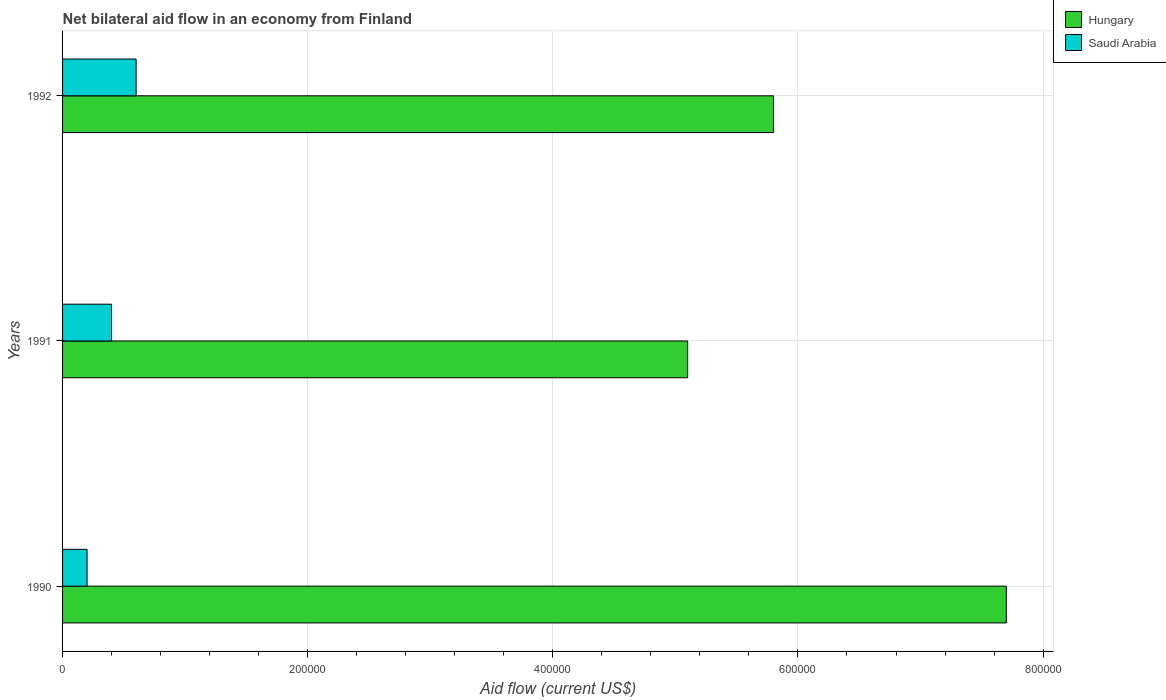How many bars are there on the 2nd tick from the top?
Keep it short and to the point. 2. In how many cases, is the number of bars for a given year not equal to the number of legend labels?
Provide a short and direct response. 0. What is the net bilateral aid flow in Hungary in 1992?
Your answer should be compact. 5.80e+05. Across all years, what is the maximum net bilateral aid flow in Hungary?
Your answer should be compact. 7.70e+05. Across all years, what is the minimum net bilateral aid flow in Hungary?
Give a very brief answer. 5.10e+05. In which year was the net bilateral aid flow in Saudi Arabia minimum?
Your answer should be compact. 1990. What is the total net bilateral aid flow in Hungary in the graph?
Keep it short and to the point. 1.86e+06. What is the difference between the net bilateral aid flow in Hungary in 1990 and that in 1991?
Ensure brevity in your answer.  2.60e+05. What is the difference between the net bilateral aid flow in Saudi Arabia in 1990 and the net bilateral aid flow in Hungary in 1991?
Make the answer very short. -4.90e+05. What is the average net bilateral aid flow in Hungary per year?
Provide a short and direct response. 6.20e+05. In the year 1992, what is the difference between the net bilateral aid flow in Hungary and net bilateral aid flow in Saudi Arabia?
Ensure brevity in your answer.  5.20e+05. In how many years, is the net bilateral aid flow in Hungary greater than 480000 US$?
Ensure brevity in your answer.  3. What is the ratio of the net bilateral aid flow in Hungary in 1990 to that in 1992?
Make the answer very short. 1.33. Is the net bilateral aid flow in Hungary in 1991 less than that in 1992?
Offer a very short reply. Yes. What does the 1st bar from the top in 1992 represents?
Ensure brevity in your answer.  Saudi Arabia. What does the 1st bar from the bottom in 1992 represents?
Your answer should be very brief. Hungary. Are all the bars in the graph horizontal?
Ensure brevity in your answer.  Yes. Does the graph contain grids?
Your answer should be compact. Yes. What is the title of the graph?
Provide a short and direct response. Net bilateral aid flow in an economy from Finland. Does "Cayman Islands" appear as one of the legend labels in the graph?
Provide a short and direct response. No. What is the label or title of the Y-axis?
Provide a succinct answer. Years. What is the Aid flow (current US$) in Hungary in 1990?
Ensure brevity in your answer.  7.70e+05. What is the Aid flow (current US$) in Hungary in 1991?
Your response must be concise. 5.10e+05. What is the Aid flow (current US$) of Hungary in 1992?
Give a very brief answer. 5.80e+05. Across all years, what is the maximum Aid flow (current US$) of Hungary?
Provide a short and direct response. 7.70e+05. Across all years, what is the maximum Aid flow (current US$) in Saudi Arabia?
Give a very brief answer. 6.00e+04. Across all years, what is the minimum Aid flow (current US$) in Hungary?
Make the answer very short. 5.10e+05. Across all years, what is the minimum Aid flow (current US$) in Saudi Arabia?
Your answer should be very brief. 2.00e+04. What is the total Aid flow (current US$) of Hungary in the graph?
Your answer should be very brief. 1.86e+06. What is the total Aid flow (current US$) of Saudi Arabia in the graph?
Ensure brevity in your answer.  1.20e+05. What is the difference between the Aid flow (current US$) of Hungary in 1990 and that in 1992?
Offer a terse response. 1.90e+05. What is the difference between the Aid flow (current US$) of Saudi Arabia in 1991 and that in 1992?
Give a very brief answer. -2.00e+04. What is the difference between the Aid flow (current US$) in Hungary in 1990 and the Aid flow (current US$) in Saudi Arabia in 1991?
Provide a succinct answer. 7.30e+05. What is the difference between the Aid flow (current US$) in Hungary in 1990 and the Aid flow (current US$) in Saudi Arabia in 1992?
Keep it short and to the point. 7.10e+05. What is the difference between the Aid flow (current US$) of Hungary in 1991 and the Aid flow (current US$) of Saudi Arabia in 1992?
Your answer should be very brief. 4.50e+05. What is the average Aid flow (current US$) of Hungary per year?
Keep it short and to the point. 6.20e+05. In the year 1990, what is the difference between the Aid flow (current US$) in Hungary and Aid flow (current US$) in Saudi Arabia?
Ensure brevity in your answer.  7.50e+05. In the year 1992, what is the difference between the Aid flow (current US$) in Hungary and Aid flow (current US$) in Saudi Arabia?
Your answer should be compact. 5.20e+05. What is the ratio of the Aid flow (current US$) of Hungary in 1990 to that in 1991?
Your response must be concise. 1.51. What is the ratio of the Aid flow (current US$) in Saudi Arabia in 1990 to that in 1991?
Offer a very short reply. 0.5. What is the ratio of the Aid flow (current US$) of Hungary in 1990 to that in 1992?
Keep it short and to the point. 1.33. What is the ratio of the Aid flow (current US$) of Hungary in 1991 to that in 1992?
Your answer should be very brief. 0.88. What is the ratio of the Aid flow (current US$) in Saudi Arabia in 1991 to that in 1992?
Offer a very short reply. 0.67. What is the difference between the highest and the second highest Aid flow (current US$) in Hungary?
Ensure brevity in your answer.  1.90e+05. What is the difference between the highest and the second highest Aid flow (current US$) in Saudi Arabia?
Your response must be concise. 2.00e+04. What is the difference between the highest and the lowest Aid flow (current US$) of Hungary?
Give a very brief answer. 2.60e+05. What is the difference between the highest and the lowest Aid flow (current US$) in Saudi Arabia?
Make the answer very short. 4.00e+04. 